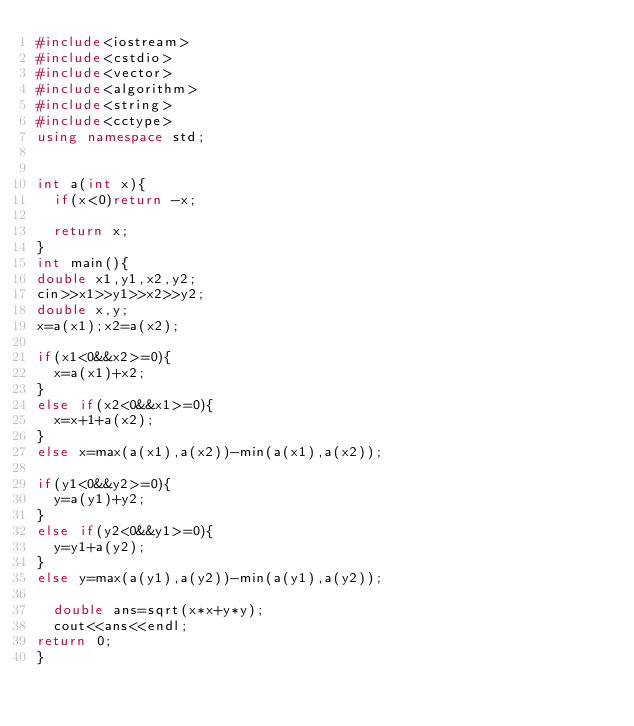Convert code to text. <code><loc_0><loc_0><loc_500><loc_500><_C++_>#include<iostream>
#include<cstdio>
#include<vector>
#include<algorithm>
#include<string>
#include<cctype>
using namespace std;


int a(int x){
	if(x<0)return -x;
	
	return x;
}
int main(){
double x1,y1,x2,y2;
cin>>x1>>y1>>x2>>y2;
double x,y;
x=a(x1);x2=a(x2);

if(x1<0&&x2>=0){
	x=a(x1)+x2;
}
else if(x2<0&&x1>=0){
	x=x+1+a(x2);
}
else x=max(a(x1),a(x2))-min(a(x1),a(x2));

if(y1<0&&y2>=0){
	y=a(y1)+y2;
}
else if(y2<0&&y1>=0){
	y=y1+a(y2);
}
else y=max(a(y1),a(y2))-min(a(y1),a(y2));
	
	double ans=sqrt(x*x+y*y);
	cout<<ans<<endl;
return 0;
}</code> 